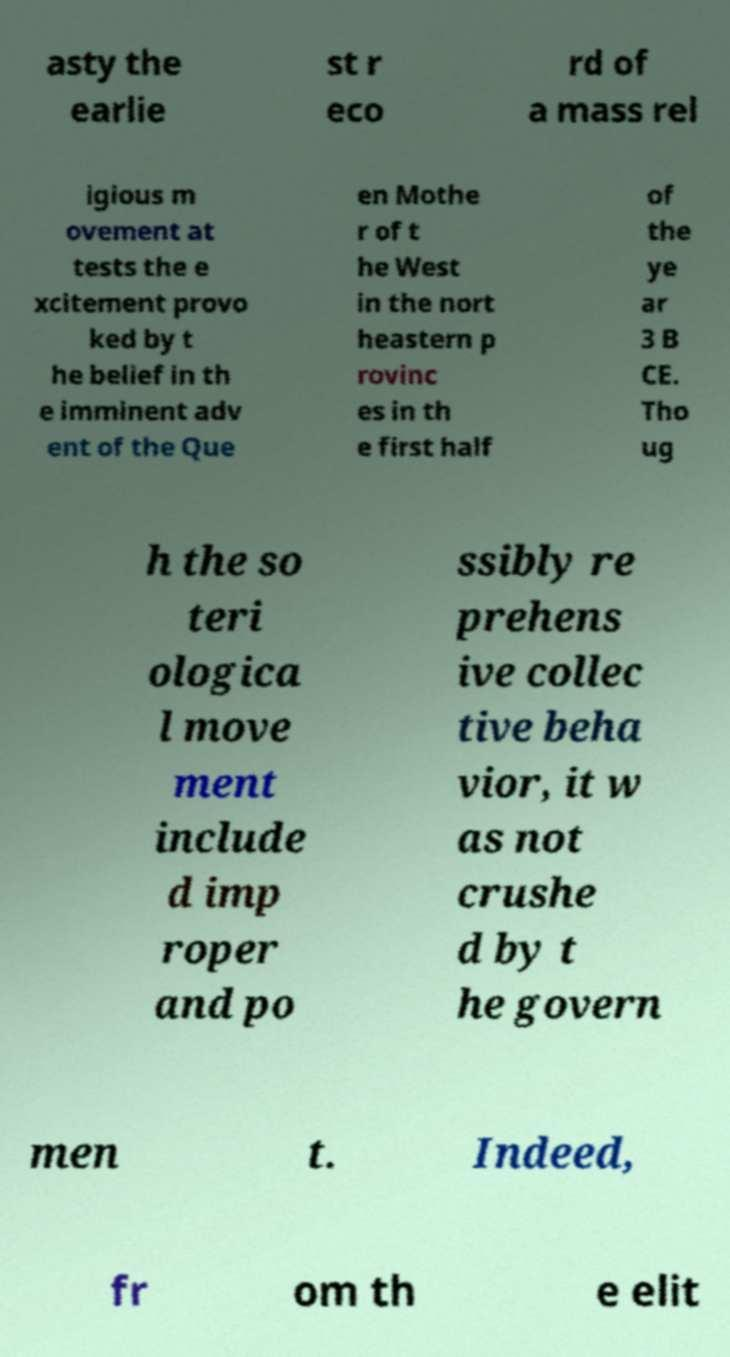For documentation purposes, I need the text within this image transcribed. Could you provide that? asty the earlie st r eco rd of a mass rel igious m ovement at tests the e xcitement provo ked by t he belief in th e imminent adv ent of the Que en Mothe r of t he West in the nort heastern p rovinc es in th e first half of the ye ar 3 B CE. Tho ug h the so teri ologica l move ment include d imp roper and po ssibly re prehens ive collec tive beha vior, it w as not crushe d by t he govern men t. Indeed, fr om th e elit 